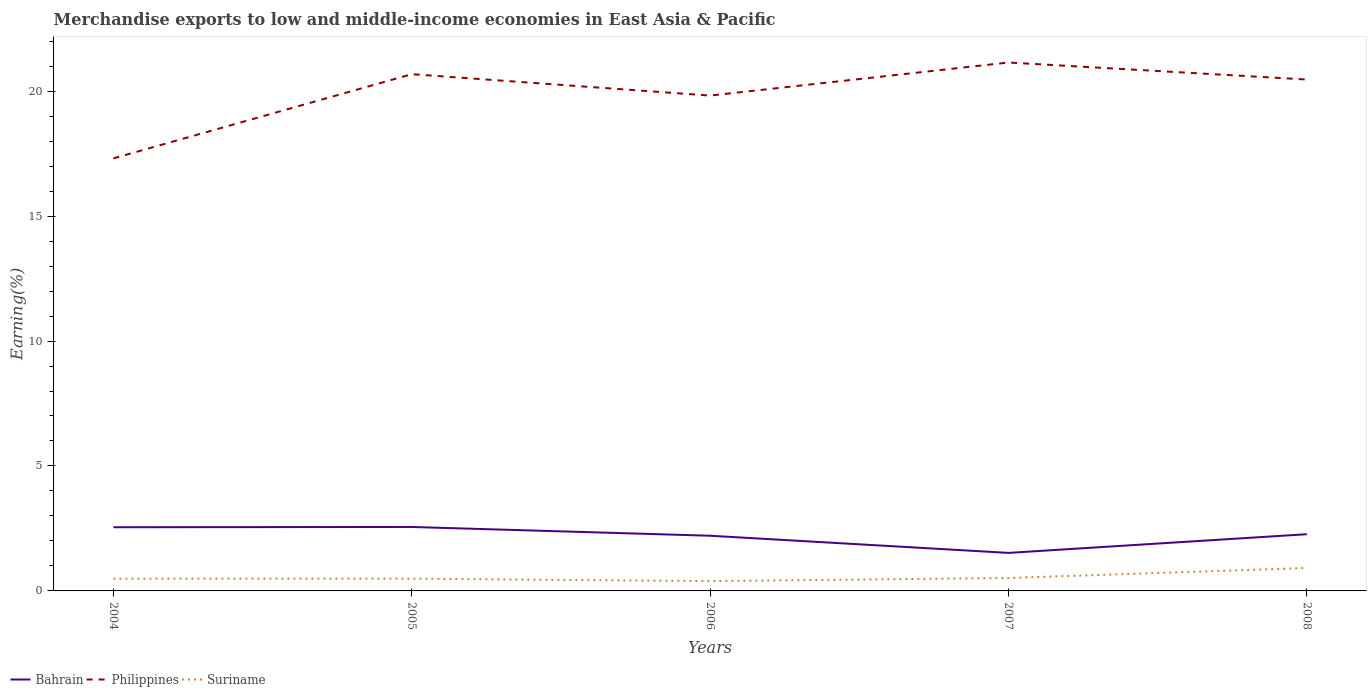How many different coloured lines are there?
Keep it short and to the point. 3. Is the number of lines equal to the number of legend labels?
Offer a very short reply. Yes. Across all years, what is the maximum percentage of amount earned from merchandise exports in Suriname?
Make the answer very short. 0.39. What is the total percentage of amount earned from merchandise exports in Philippines in the graph?
Your answer should be compact. -3.16. What is the difference between the highest and the second highest percentage of amount earned from merchandise exports in Suriname?
Provide a succinct answer. 0.53. What is the difference between the highest and the lowest percentage of amount earned from merchandise exports in Suriname?
Your answer should be compact. 1. Is the percentage of amount earned from merchandise exports in Bahrain strictly greater than the percentage of amount earned from merchandise exports in Suriname over the years?
Your response must be concise. No. How many years are there in the graph?
Keep it short and to the point. 5. Does the graph contain grids?
Your response must be concise. No. How many legend labels are there?
Provide a succinct answer. 3. What is the title of the graph?
Offer a terse response. Merchandise exports to low and middle-income economies in East Asia & Pacific. What is the label or title of the Y-axis?
Give a very brief answer. Earning(%). What is the Earning(%) of Bahrain in 2004?
Offer a terse response. 2.55. What is the Earning(%) of Philippines in 2004?
Your answer should be compact. 17.31. What is the Earning(%) in Suriname in 2004?
Your answer should be very brief. 0.49. What is the Earning(%) in Bahrain in 2005?
Provide a succinct answer. 2.56. What is the Earning(%) in Philippines in 2005?
Give a very brief answer. 20.68. What is the Earning(%) of Suriname in 2005?
Keep it short and to the point. 0.49. What is the Earning(%) in Bahrain in 2006?
Your answer should be compact. 2.21. What is the Earning(%) in Philippines in 2006?
Your answer should be compact. 19.82. What is the Earning(%) in Suriname in 2006?
Give a very brief answer. 0.39. What is the Earning(%) of Bahrain in 2007?
Provide a short and direct response. 1.52. What is the Earning(%) in Philippines in 2007?
Your answer should be compact. 21.15. What is the Earning(%) of Suriname in 2007?
Give a very brief answer. 0.52. What is the Earning(%) in Bahrain in 2008?
Make the answer very short. 2.27. What is the Earning(%) in Philippines in 2008?
Give a very brief answer. 20.46. What is the Earning(%) of Suriname in 2008?
Your answer should be very brief. 0.92. Across all years, what is the maximum Earning(%) in Bahrain?
Your response must be concise. 2.56. Across all years, what is the maximum Earning(%) of Philippines?
Your answer should be compact. 21.15. Across all years, what is the maximum Earning(%) in Suriname?
Your response must be concise. 0.92. Across all years, what is the minimum Earning(%) in Bahrain?
Offer a terse response. 1.52. Across all years, what is the minimum Earning(%) in Philippines?
Keep it short and to the point. 17.31. Across all years, what is the minimum Earning(%) of Suriname?
Offer a terse response. 0.39. What is the total Earning(%) in Bahrain in the graph?
Offer a very short reply. 11.11. What is the total Earning(%) in Philippines in the graph?
Offer a very short reply. 99.42. What is the total Earning(%) in Suriname in the graph?
Your response must be concise. 2.81. What is the difference between the Earning(%) in Bahrain in 2004 and that in 2005?
Keep it short and to the point. -0.01. What is the difference between the Earning(%) in Philippines in 2004 and that in 2005?
Provide a succinct answer. -3.37. What is the difference between the Earning(%) of Suriname in 2004 and that in 2005?
Ensure brevity in your answer.  -0. What is the difference between the Earning(%) in Bahrain in 2004 and that in 2006?
Offer a very short reply. 0.34. What is the difference between the Earning(%) of Philippines in 2004 and that in 2006?
Your response must be concise. -2.51. What is the difference between the Earning(%) of Suriname in 2004 and that in 2006?
Give a very brief answer. 0.1. What is the difference between the Earning(%) in Bahrain in 2004 and that in 2007?
Provide a succinct answer. 1.03. What is the difference between the Earning(%) of Philippines in 2004 and that in 2007?
Keep it short and to the point. -3.84. What is the difference between the Earning(%) in Suriname in 2004 and that in 2007?
Give a very brief answer. -0.03. What is the difference between the Earning(%) in Bahrain in 2004 and that in 2008?
Offer a very short reply. 0.28. What is the difference between the Earning(%) of Philippines in 2004 and that in 2008?
Keep it short and to the point. -3.16. What is the difference between the Earning(%) of Suriname in 2004 and that in 2008?
Your answer should be very brief. -0.43. What is the difference between the Earning(%) of Bahrain in 2005 and that in 2006?
Offer a terse response. 0.35. What is the difference between the Earning(%) of Philippines in 2005 and that in 2006?
Make the answer very short. 0.86. What is the difference between the Earning(%) of Suriname in 2005 and that in 2006?
Your answer should be compact. 0.1. What is the difference between the Earning(%) of Bahrain in 2005 and that in 2007?
Offer a terse response. 1.04. What is the difference between the Earning(%) in Philippines in 2005 and that in 2007?
Your response must be concise. -0.47. What is the difference between the Earning(%) of Suriname in 2005 and that in 2007?
Make the answer very short. -0.03. What is the difference between the Earning(%) of Bahrain in 2005 and that in 2008?
Keep it short and to the point. 0.29. What is the difference between the Earning(%) in Philippines in 2005 and that in 2008?
Ensure brevity in your answer.  0.21. What is the difference between the Earning(%) of Suriname in 2005 and that in 2008?
Your answer should be compact. -0.43. What is the difference between the Earning(%) in Bahrain in 2006 and that in 2007?
Your response must be concise. 0.69. What is the difference between the Earning(%) in Philippines in 2006 and that in 2007?
Keep it short and to the point. -1.32. What is the difference between the Earning(%) of Suriname in 2006 and that in 2007?
Give a very brief answer. -0.13. What is the difference between the Earning(%) in Bahrain in 2006 and that in 2008?
Make the answer very short. -0.06. What is the difference between the Earning(%) of Philippines in 2006 and that in 2008?
Provide a succinct answer. -0.64. What is the difference between the Earning(%) of Suriname in 2006 and that in 2008?
Your answer should be compact. -0.53. What is the difference between the Earning(%) in Bahrain in 2007 and that in 2008?
Keep it short and to the point. -0.75. What is the difference between the Earning(%) of Philippines in 2007 and that in 2008?
Your response must be concise. 0.68. What is the difference between the Earning(%) of Suriname in 2007 and that in 2008?
Provide a short and direct response. -0.4. What is the difference between the Earning(%) in Bahrain in 2004 and the Earning(%) in Philippines in 2005?
Offer a terse response. -18.13. What is the difference between the Earning(%) in Bahrain in 2004 and the Earning(%) in Suriname in 2005?
Your response must be concise. 2.06. What is the difference between the Earning(%) of Philippines in 2004 and the Earning(%) of Suriname in 2005?
Provide a succinct answer. 16.82. What is the difference between the Earning(%) in Bahrain in 2004 and the Earning(%) in Philippines in 2006?
Your answer should be very brief. -17.27. What is the difference between the Earning(%) in Bahrain in 2004 and the Earning(%) in Suriname in 2006?
Ensure brevity in your answer.  2.16. What is the difference between the Earning(%) of Philippines in 2004 and the Earning(%) of Suriname in 2006?
Your answer should be compact. 16.92. What is the difference between the Earning(%) of Bahrain in 2004 and the Earning(%) of Philippines in 2007?
Provide a short and direct response. -18.6. What is the difference between the Earning(%) of Bahrain in 2004 and the Earning(%) of Suriname in 2007?
Your answer should be very brief. 2.03. What is the difference between the Earning(%) in Philippines in 2004 and the Earning(%) in Suriname in 2007?
Offer a terse response. 16.79. What is the difference between the Earning(%) in Bahrain in 2004 and the Earning(%) in Philippines in 2008?
Provide a short and direct response. -17.92. What is the difference between the Earning(%) of Bahrain in 2004 and the Earning(%) of Suriname in 2008?
Your answer should be compact. 1.63. What is the difference between the Earning(%) of Philippines in 2004 and the Earning(%) of Suriname in 2008?
Make the answer very short. 16.39. What is the difference between the Earning(%) in Bahrain in 2005 and the Earning(%) in Philippines in 2006?
Your response must be concise. -17.26. What is the difference between the Earning(%) of Bahrain in 2005 and the Earning(%) of Suriname in 2006?
Ensure brevity in your answer.  2.17. What is the difference between the Earning(%) in Philippines in 2005 and the Earning(%) in Suriname in 2006?
Ensure brevity in your answer.  20.29. What is the difference between the Earning(%) in Bahrain in 2005 and the Earning(%) in Philippines in 2007?
Provide a succinct answer. -18.59. What is the difference between the Earning(%) of Bahrain in 2005 and the Earning(%) of Suriname in 2007?
Keep it short and to the point. 2.04. What is the difference between the Earning(%) of Philippines in 2005 and the Earning(%) of Suriname in 2007?
Offer a terse response. 20.16. What is the difference between the Earning(%) in Bahrain in 2005 and the Earning(%) in Philippines in 2008?
Give a very brief answer. -17.91. What is the difference between the Earning(%) in Bahrain in 2005 and the Earning(%) in Suriname in 2008?
Your response must be concise. 1.64. What is the difference between the Earning(%) of Philippines in 2005 and the Earning(%) of Suriname in 2008?
Your answer should be very brief. 19.76. What is the difference between the Earning(%) in Bahrain in 2006 and the Earning(%) in Philippines in 2007?
Your answer should be very brief. -18.94. What is the difference between the Earning(%) of Bahrain in 2006 and the Earning(%) of Suriname in 2007?
Your answer should be very brief. 1.69. What is the difference between the Earning(%) in Philippines in 2006 and the Earning(%) in Suriname in 2007?
Provide a short and direct response. 19.3. What is the difference between the Earning(%) of Bahrain in 2006 and the Earning(%) of Philippines in 2008?
Ensure brevity in your answer.  -18.26. What is the difference between the Earning(%) of Bahrain in 2006 and the Earning(%) of Suriname in 2008?
Provide a succinct answer. 1.29. What is the difference between the Earning(%) of Philippines in 2006 and the Earning(%) of Suriname in 2008?
Provide a short and direct response. 18.9. What is the difference between the Earning(%) in Bahrain in 2007 and the Earning(%) in Philippines in 2008?
Ensure brevity in your answer.  -18.94. What is the difference between the Earning(%) of Bahrain in 2007 and the Earning(%) of Suriname in 2008?
Offer a very short reply. 0.6. What is the difference between the Earning(%) of Philippines in 2007 and the Earning(%) of Suriname in 2008?
Your answer should be compact. 20.23. What is the average Earning(%) in Bahrain per year?
Provide a short and direct response. 2.22. What is the average Earning(%) of Philippines per year?
Ensure brevity in your answer.  19.88. What is the average Earning(%) in Suriname per year?
Your answer should be very brief. 0.56. In the year 2004, what is the difference between the Earning(%) in Bahrain and Earning(%) in Philippines?
Keep it short and to the point. -14.76. In the year 2004, what is the difference between the Earning(%) in Bahrain and Earning(%) in Suriname?
Provide a short and direct response. 2.06. In the year 2004, what is the difference between the Earning(%) of Philippines and Earning(%) of Suriname?
Keep it short and to the point. 16.82. In the year 2005, what is the difference between the Earning(%) of Bahrain and Earning(%) of Philippines?
Keep it short and to the point. -18.12. In the year 2005, what is the difference between the Earning(%) in Bahrain and Earning(%) in Suriname?
Your response must be concise. 2.07. In the year 2005, what is the difference between the Earning(%) of Philippines and Earning(%) of Suriname?
Give a very brief answer. 20.19. In the year 2006, what is the difference between the Earning(%) in Bahrain and Earning(%) in Philippines?
Offer a terse response. -17.61. In the year 2006, what is the difference between the Earning(%) in Bahrain and Earning(%) in Suriname?
Your answer should be compact. 1.82. In the year 2006, what is the difference between the Earning(%) of Philippines and Earning(%) of Suriname?
Your response must be concise. 19.43. In the year 2007, what is the difference between the Earning(%) of Bahrain and Earning(%) of Philippines?
Your response must be concise. -19.62. In the year 2007, what is the difference between the Earning(%) of Bahrain and Earning(%) of Suriname?
Provide a succinct answer. 1. In the year 2007, what is the difference between the Earning(%) of Philippines and Earning(%) of Suriname?
Your answer should be compact. 20.63. In the year 2008, what is the difference between the Earning(%) of Bahrain and Earning(%) of Philippines?
Your answer should be very brief. -18.2. In the year 2008, what is the difference between the Earning(%) in Bahrain and Earning(%) in Suriname?
Offer a very short reply. 1.35. In the year 2008, what is the difference between the Earning(%) of Philippines and Earning(%) of Suriname?
Make the answer very short. 19.55. What is the ratio of the Earning(%) in Philippines in 2004 to that in 2005?
Offer a terse response. 0.84. What is the ratio of the Earning(%) in Bahrain in 2004 to that in 2006?
Make the answer very short. 1.15. What is the ratio of the Earning(%) in Philippines in 2004 to that in 2006?
Make the answer very short. 0.87. What is the ratio of the Earning(%) in Suriname in 2004 to that in 2006?
Offer a very short reply. 1.25. What is the ratio of the Earning(%) of Bahrain in 2004 to that in 2007?
Your answer should be compact. 1.67. What is the ratio of the Earning(%) of Philippines in 2004 to that in 2007?
Provide a short and direct response. 0.82. What is the ratio of the Earning(%) in Suriname in 2004 to that in 2007?
Provide a short and direct response. 0.95. What is the ratio of the Earning(%) in Bahrain in 2004 to that in 2008?
Give a very brief answer. 1.12. What is the ratio of the Earning(%) in Philippines in 2004 to that in 2008?
Provide a succinct answer. 0.85. What is the ratio of the Earning(%) of Suriname in 2004 to that in 2008?
Provide a succinct answer. 0.54. What is the ratio of the Earning(%) of Bahrain in 2005 to that in 2006?
Provide a succinct answer. 1.16. What is the ratio of the Earning(%) of Philippines in 2005 to that in 2006?
Your answer should be compact. 1.04. What is the ratio of the Earning(%) in Suriname in 2005 to that in 2006?
Your answer should be compact. 1.25. What is the ratio of the Earning(%) in Bahrain in 2005 to that in 2007?
Make the answer very short. 1.68. What is the ratio of the Earning(%) in Philippines in 2005 to that in 2007?
Your response must be concise. 0.98. What is the ratio of the Earning(%) of Suriname in 2005 to that in 2007?
Keep it short and to the point. 0.95. What is the ratio of the Earning(%) in Bahrain in 2005 to that in 2008?
Provide a short and direct response. 1.13. What is the ratio of the Earning(%) of Philippines in 2005 to that in 2008?
Offer a terse response. 1.01. What is the ratio of the Earning(%) in Suriname in 2005 to that in 2008?
Offer a very short reply. 0.54. What is the ratio of the Earning(%) of Bahrain in 2006 to that in 2007?
Ensure brevity in your answer.  1.45. What is the ratio of the Earning(%) of Philippines in 2006 to that in 2007?
Offer a terse response. 0.94. What is the ratio of the Earning(%) in Suriname in 2006 to that in 2007?
Your answer should be compact. 0.76. What is the ratio of the Earning(%) of Bahrain in 2006 to that in 2008?
Give a very brief answer. 0.97. What is the ratio of the Earning(%) of Philippines in 2006 to that in 2008?
Your answer should be very brief. 0.97. What is the ratio of the Earning(%) of Suriname in 2006 to that in 2008?
Provide a succinct answer. 0.43. What is the ratio of the Earning(%) in Bahrain in 2007 to that in 2008?
Make the answer very short. 0.67. What is the ratio of the Earning(%) in Philippines in 2007 to that in 2008?
Provide a succinct answer. 1.03. What is the ratio of the Earning(%) in Suriname in 2007 to that in 2008?
Give a very brief answer. 0.56. What is the difference between the highest and the second highest Earning(%) of Bahrain?
Keep it short and to the point. 0.01. What is the difference between the highest and the second highest Earning(%) of Philippines?
Ensure brevity in your answer.  0.47. What is the difference between the highest and the second highest Earning(%) of Suriname?
Offer a terse response. 0.4. What is the difference between the highest and the lowest Earning(%) of Bahrain?
Give a very brief answer. 1.04. What is the difference between the highest and the lowest Earning(%) in Philippines?
Your answer should be very brief. 3.84. What is the difference between the highest and the lowest Earning(%) in Suriname?
Offer a very short reply. 0.53. 